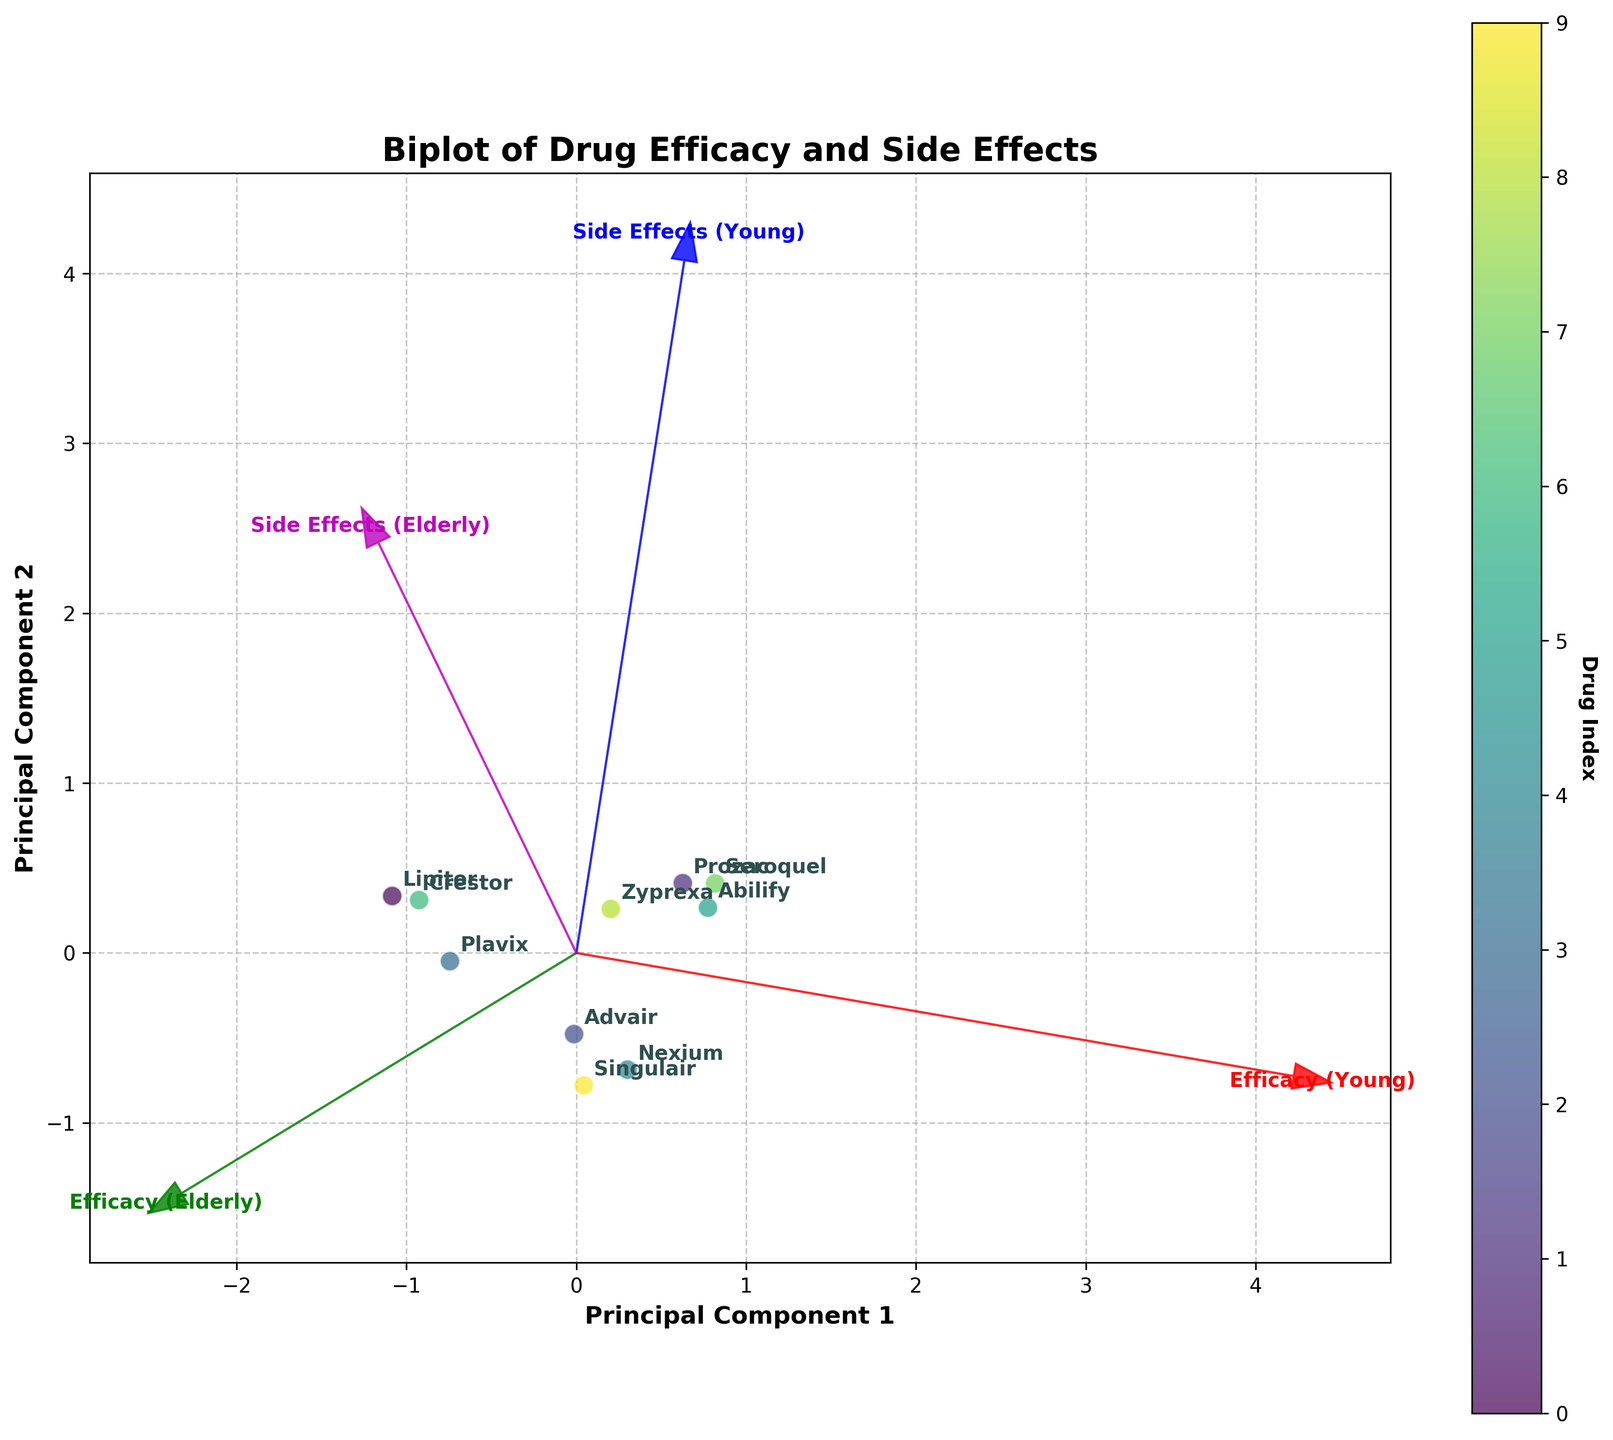What is the title of the biplot? The title is displayed at the top center of the figure, indicating the overall theme or subject of the visualization.
Answer: Biplot of Drug Efficacy and Side Effects How many drugs are analyzed in the biplot? Each drug is represented as a labeled data point. By counting these labeled points, one can determine the total number of drugs analyzed.
Answer: 10 Which drug shows the highest efficacy in young patients? By observing the positioning of the data points on the biplot, identify the one with the highest value along the 'Efficacy (Young)' vector.
Answer: Abilify Which drug has the highest side effects in elderly patients? By examining the data points, look for the one positioned highest along the 'Side Effects (Elderly)' vector.
Answer: Lipitor What is the relationship between the efficacy for young and elderly patients for the drug Lipitor? Compare the positions of Lipitor along the 'Efficacy (Young)' and 'Efficacy (Elderly)' vectors to determine the relationship.
Answer: Higher for elderly Which two drugs have the similar efficacy and side effects on young patients? Find two drugs that are positioned close to each other both along the 'Efficacy (Young)' and 'Side Effects (Young)' vectors.
Answer: Zyprexa and Singulair Does any drug show a reverse trend in efficacy or side effects between young and elderly patients, such as high in one group but low in another? Identify any drug positioned high along a vector for one group and low for the same vector for the other group to spot reverse trends.
Answer: Seroquel What is the direction of the 'Efficacy (Elderly)' feature vector relative to the 'Side Effects (Young)' vector? Analyze the arrows representing the vectors to determine their relative directions.
Answer: They are not aligned, indicating different factors affect the two features Can you infer if there is a correlation between efficacy in elderly patients and side effects in young patients? Look at the directions of the vectors 'Efficacy (Elderly)' and 'Side Effects (Young)' to deduce any potential correlation.
Answer: There seems to be no strong correlation, as vectors are not closely aligned 